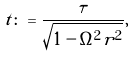<formula> <loc_0><loc_0><loc_500><loc_500>t \colon = \frac { \tau } { \sqrt { 1 - \Omega ^ { 2 } r ^ { 2 } } } ,</formula> 